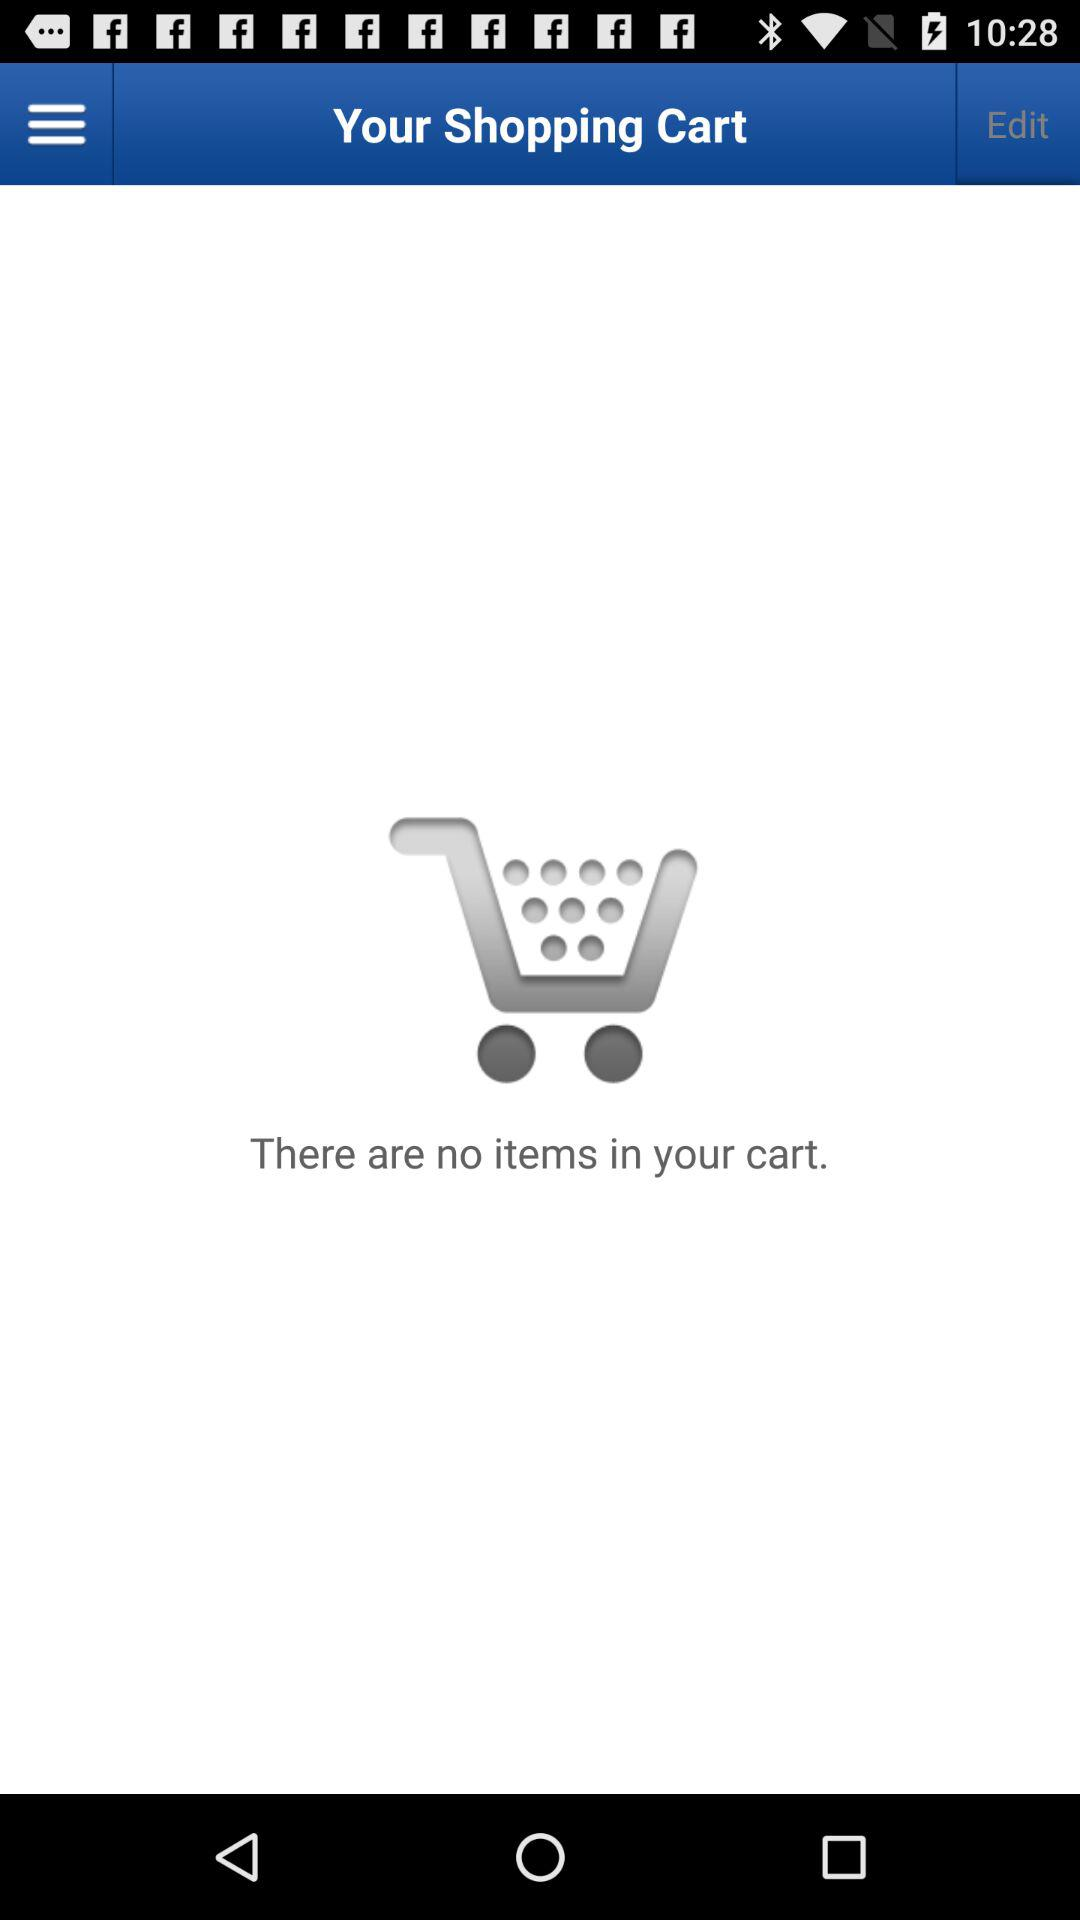How many items are in the shopping cart?
Answer the question using a single word or phrase. 0 